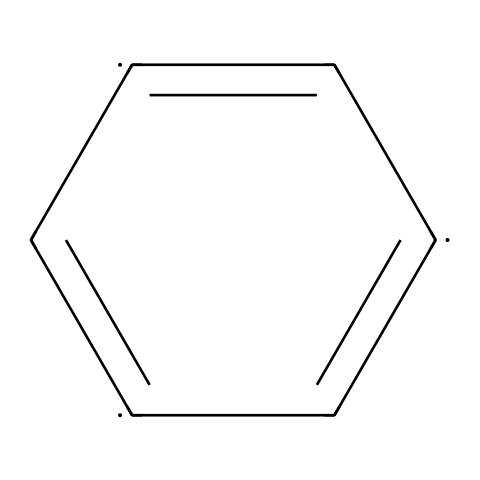What type of atomic arrangement does this chemical have? The chemical structure represents a planar arrangement of carbon atoms in a hexagonal lattice, which characterizes graphene.
Answer: planar hexagonal lattice How many carbon atoms are in the structure? By analyzing the SMILES notation, there are four distinct carbon atoms represented in the structure.
Answer: four What type of bonds are present in this chemical? The structure features alternating single and double bonds between the carbon atoms, indicating the presence of conjugated pi bonds common in aromatic compounds.
Answer: alternating single and double bonds Is this chemical a conductor or an insulator? The electron configuration in graphene allows for free movement of electrons, making it a good conductor of electricity.
Answer: conductor How many double bonds exist in the structure? By examining the structure, it can be identified that there are two double bonds present among the carbon atoms.
Answer: two What element is primarily represented in the chemical? The SMILES notation clearly indicates that the only element represented is carbon, as it is the only type of atom denoted.
Answer: carbon What is the significance of the resonance in this chemical? The alternating double bonds create resonance, which stabilizes the structure and contributes to the unique electronic properties of graphene.
Answer: stabilizes structure 